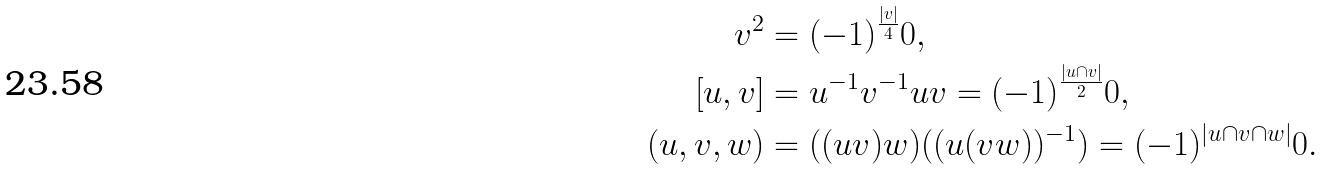Convert formula to latex. <formula><loc_0><loc_0><loc_500><loc_500>v ^ { 2 } & = ( - 1 ) ^ { \frac { | v | } { 4 } } 0 , \\ \left [ u , v \right ] & = u ^ { - 1 } v ^ { - 1 } u v = ( - 1 ) ^ { \frac { | u \cap v | } { 2 } } 0 , \\ ( u , v , w ) & = ( ( u v ) w ) ( ( u ( v w ) ) ^ { - 1 } ) = ( - 1 ) ^ { | u \cap v \cap w | } 0 .</formula> 